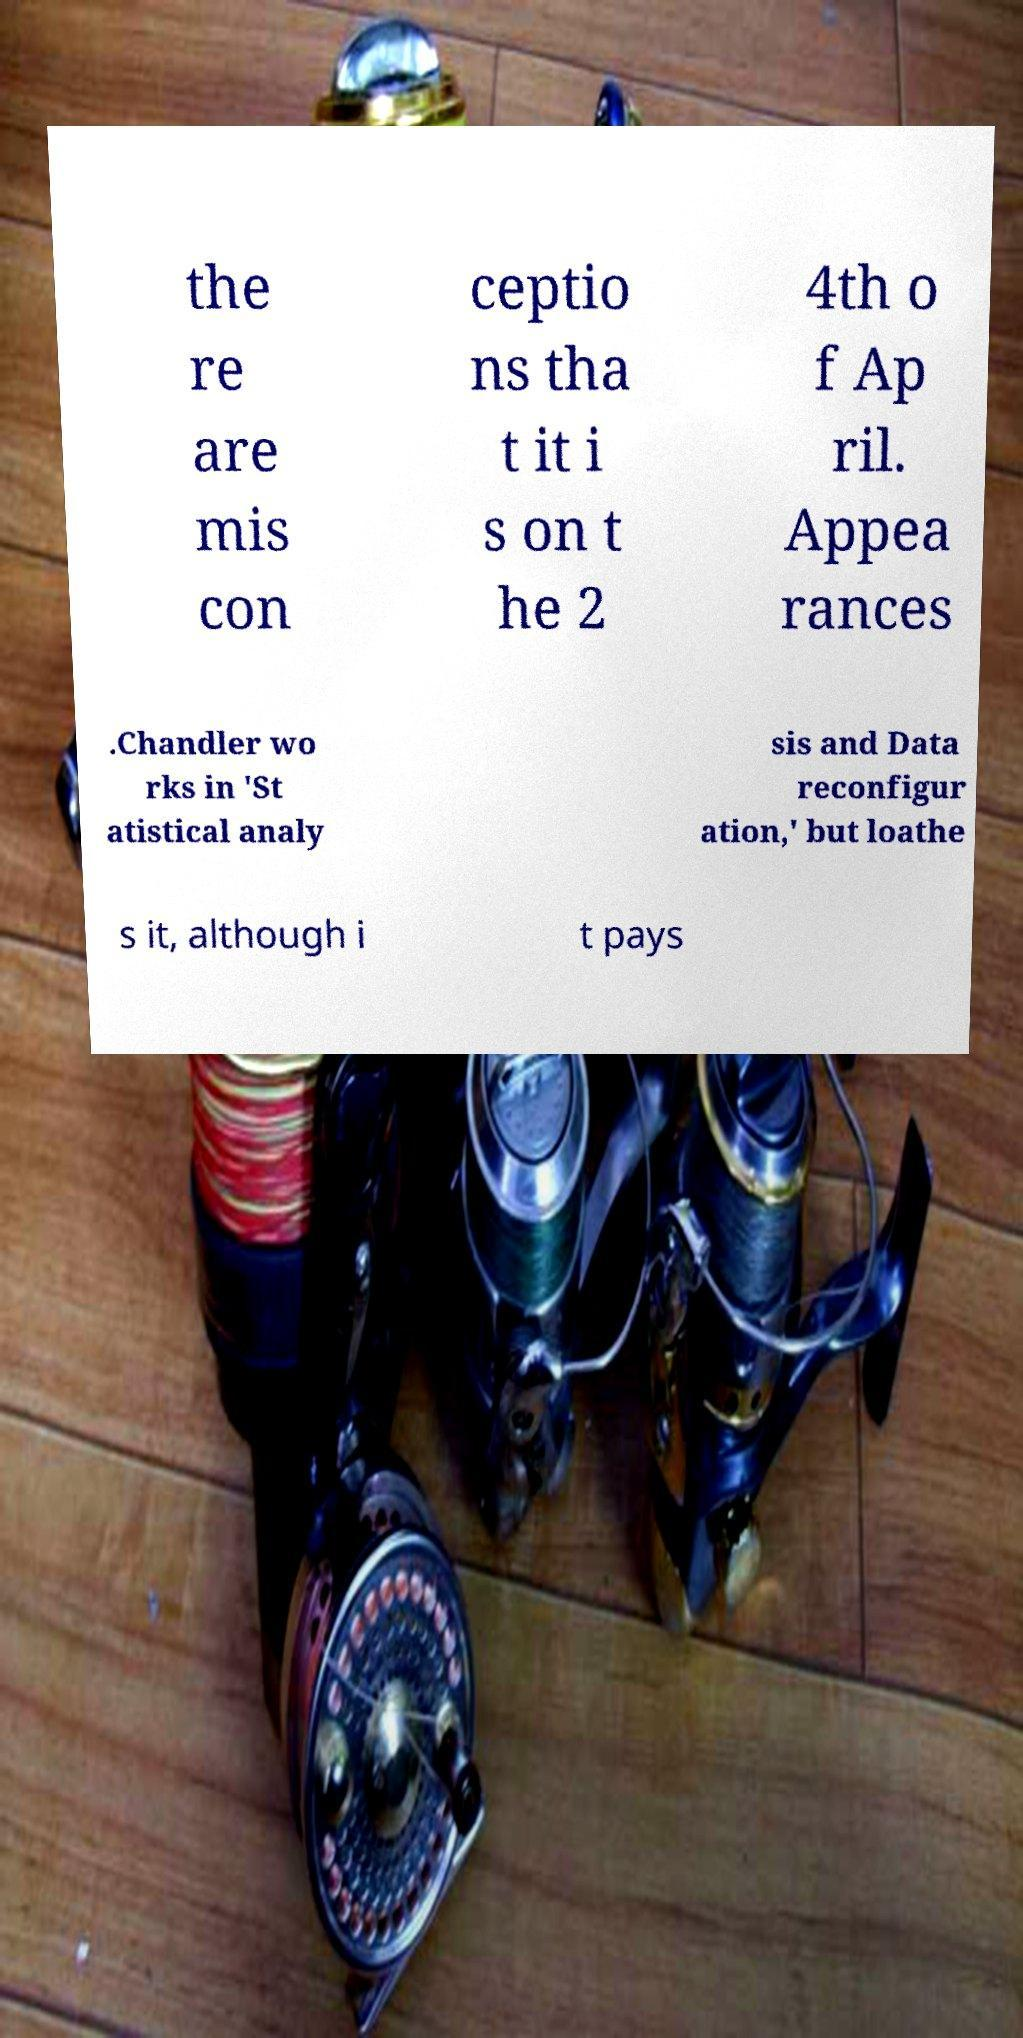For documentation purposes, I need the text within this image transcribed. Could you provide that? the re are mis con ceptio ns tha t it i s on t he 2 4th o f Ap ril. Appea rances .Chandler wo rks in 'St atistical analy sis and Data reconfigur ation,' but loathe s it, although i t pays 